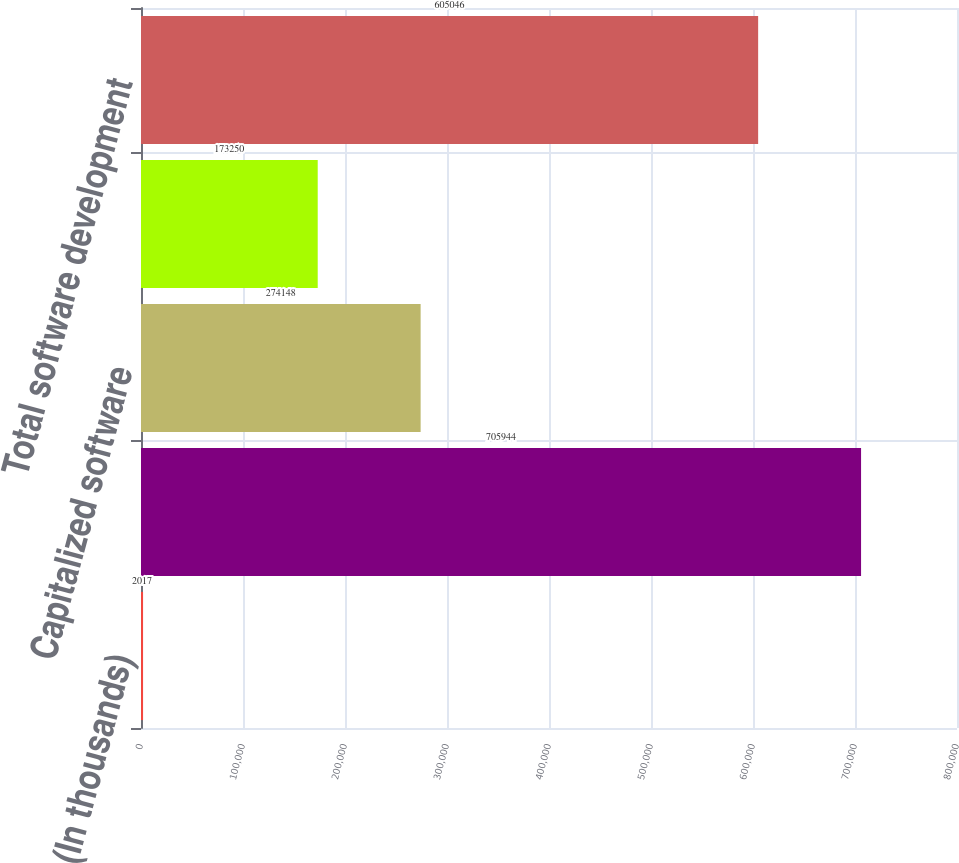Convert chart to OTSL. <chart><loc_0><loc_0><loc_500><loc_500><bar_chart><fcel>(In thousands)<fcel>Software development costs<fcel>Capitalized software<fcel>Amortization of capitalized<fcel>Total software development<nl><fcel>2017<fcel>705944<fcel>274148<fcel>173250<fcel>605046<nl></chart> 